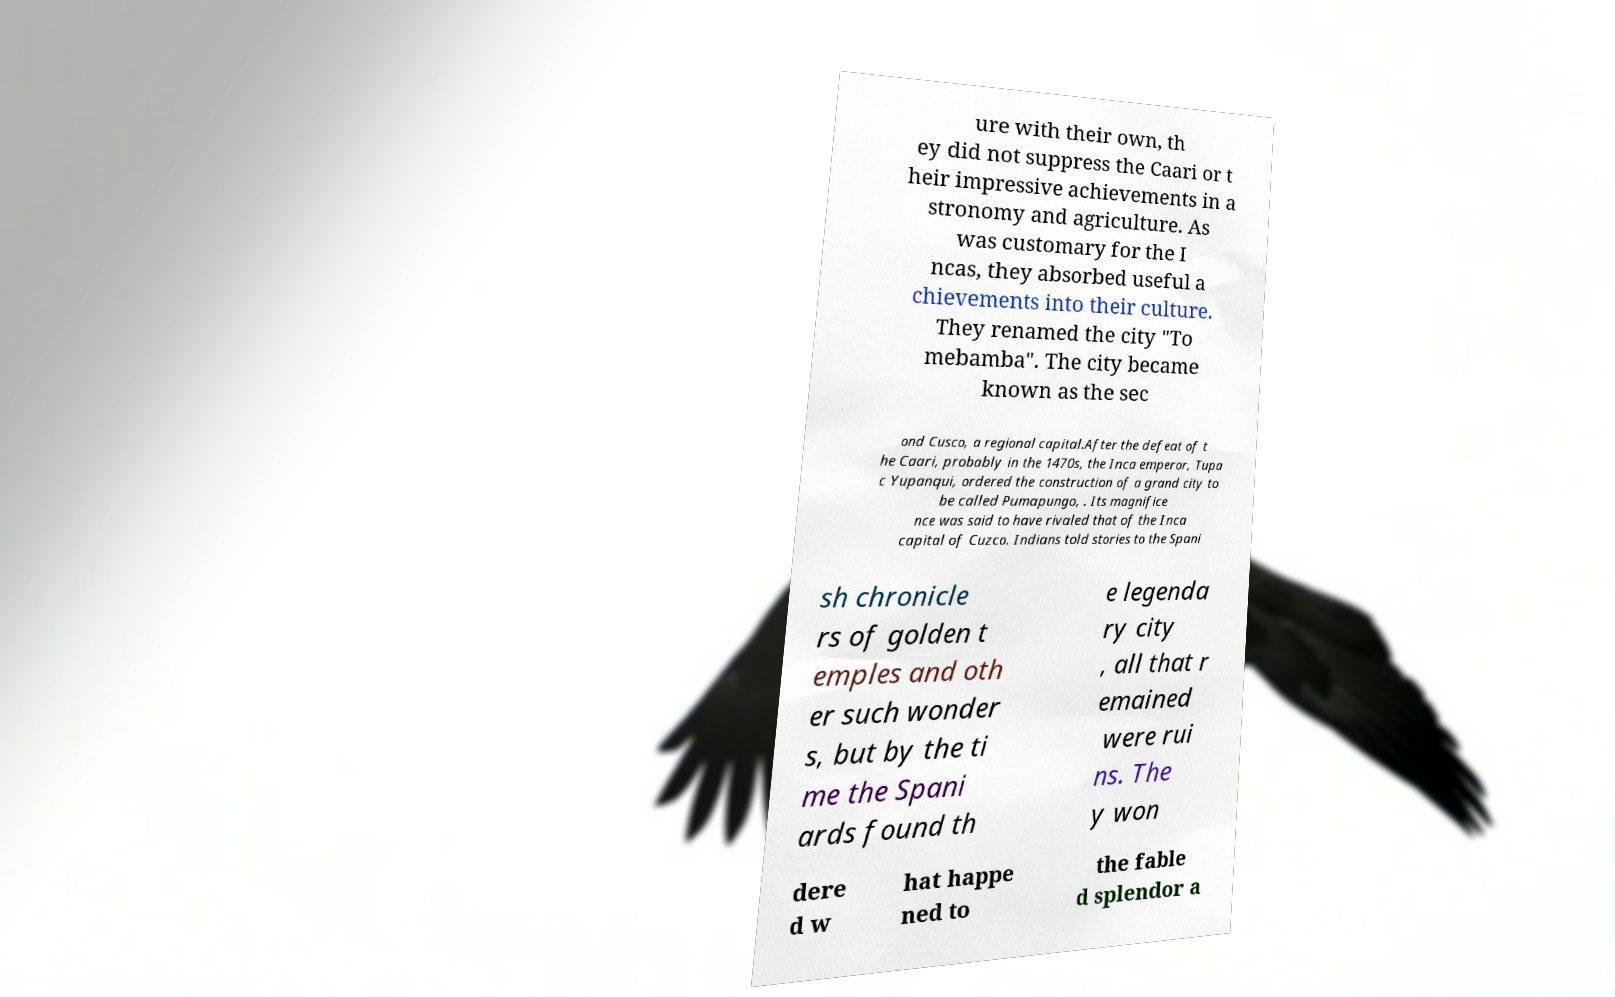Can you accurately transcribe the text from the provided image for me? ure with their own, th ey did not suppress the Caari or t heir impressive achievements in a stronomy and agriculture. As was customary for the I ncas, they absorbed useful a chievements into their culture. They renamed the city "To mebamba". The city became known as the sec ond Cusco, a regional capital.After the defeat of t he Caari, probably in the 1470s, the Inca emperor, Tupa c Yupanqui, ordered the construction of a grand city to be called Pumapungo, . Its magnifice nce was said to have rivaled that of the Inca capital of Cuzco. Indians told stories to the Spani sh chronicle rs of golden t emples and oth er such wonder s, but by the ti me the Spani ards found th e legenda ry city , all that r emained were rui ns. The y won dere d w hat happe ned to the fable d splendor a 